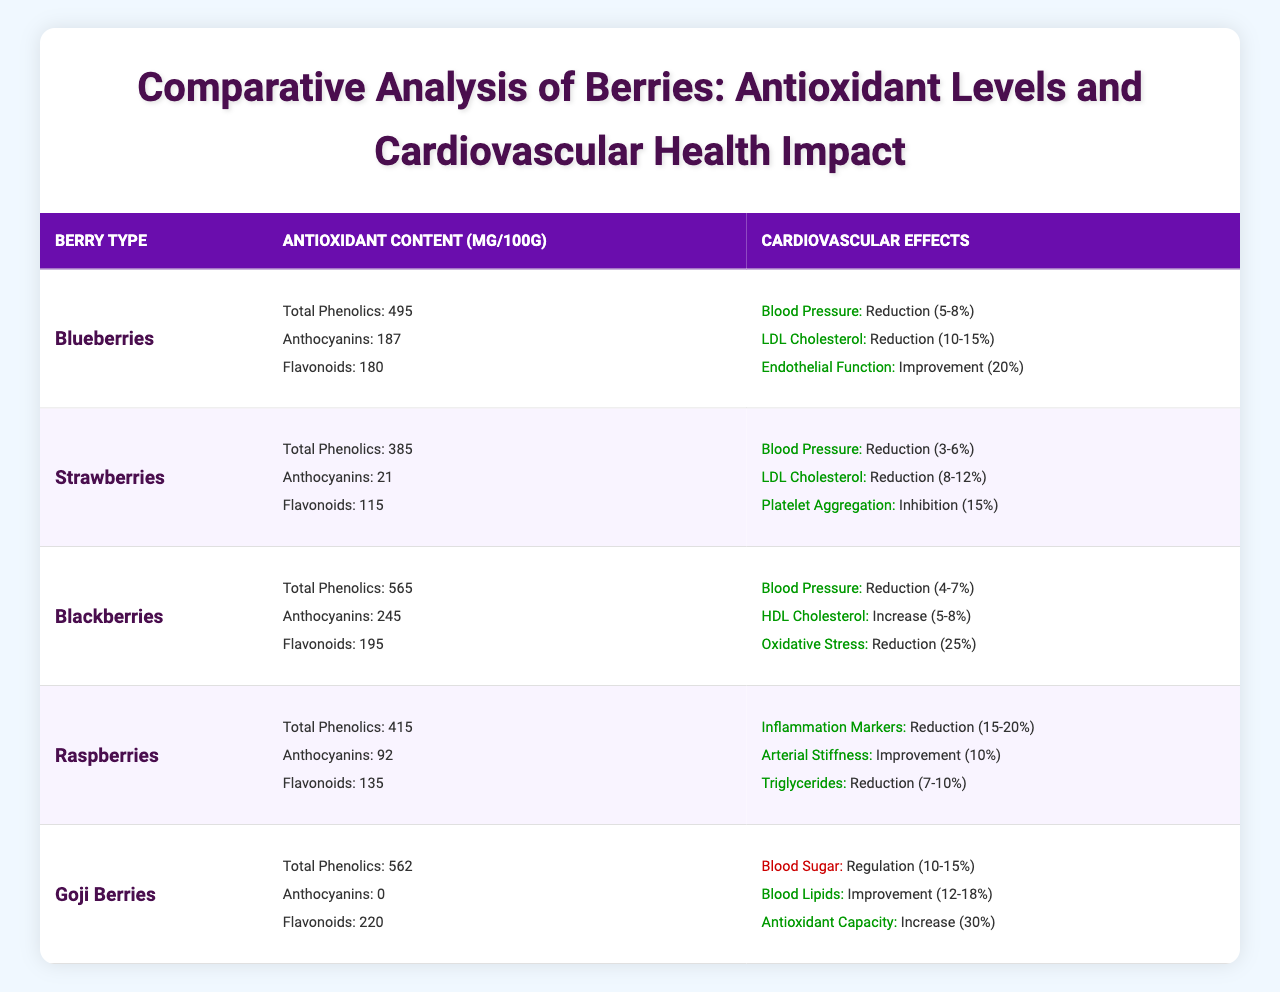What is the antioxidant content in Blueberries for total phenolics? In the table under Blueberries, the antioxidant content for total phenolics is listed as 495 mg/100g.
Answer: 495 mg/100g Which berry has the highest anthocyanin content? By comparing the anthocyanin content of each berry in the table, Blackberries have the highest at 245 mg/100g.
Answer: Blackberries What is the average reduction in LDL cholesterol for Blueberries and Strawberries? For Blueberries, the LDL cholesterol reduction is 10-15%, and for Strawberries, it is 8-12%. The average range can be calculated: (10+8) = 18% (low end) and (15+12) = 27% (high end). Therefore, the average reduction in LDL cholesterol is 18-27%.
Answer: 18-27% Do Raspberries improve arterial stiffness? Yes, according to the table, Raspberries show an improvement in arterial stiffness by 10%.
Answer: Yes Which berries have effects on both blood pressure and cholesterol? By examining the cardiovascular effects column for each berry, Blueberries and Strawberries result in reductions in blood pressure and LDL cholesterol. Both berries have documented effects on these cardiovascular parameters.
Answer: Blueberries and Strawberries What is the total antioxidant content in mg/100g for Blackberries? Total antioxidant content in mg/100g for Blackberries is composed of total phenolics (565), anthocyanins (245), and flavonoids (195). Adding these together gives 565 + 245 + 195 = 1005 mg/100g.
Answer: 1005 mg/100g Is there a berry that shows improvement in HDL cholesterol? Yes, the table indicates that Blackberries have an increase in HDL cholesterol by 5-8%.
Answer: Yes Which berry shows the greatest effect on oxidative stress? The table shows that Blackberries have a reduction in oxidative stress by 25%, which is the greatest effect compared to others.
Answer: Blackberries What is the percentage reduction in inflammation markers observed in Raspberries? According to the table, Raspberries show a reduction in inflammation markers ranging from 15-20%.
Answer: 15-20% 